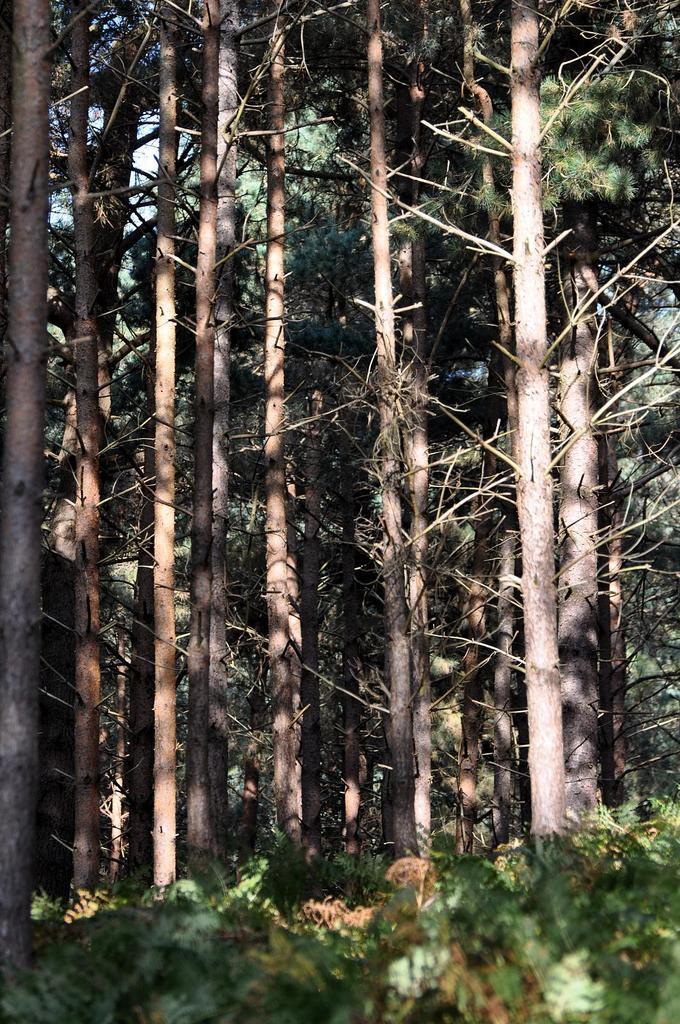Describe this image in one or two sentences. In this picture we can see trees, at the bottom there are some plants, we can see the sky in the background. 